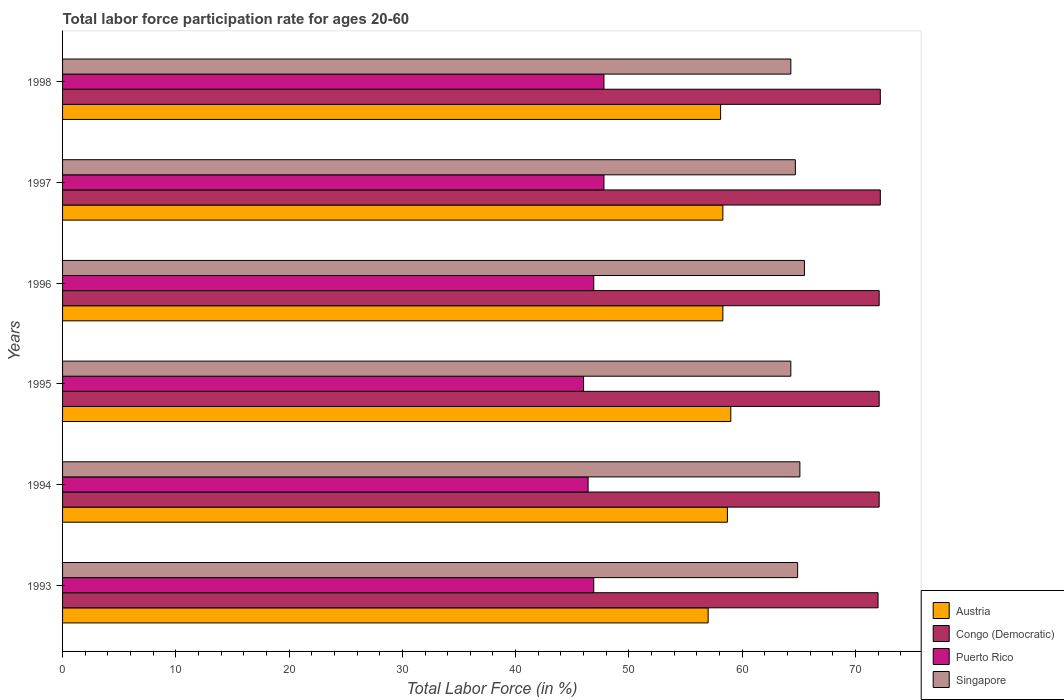Are the number of bars per tick equal to the number of legend labels?
Offer a terse response. Yes. Are the number of bars on each tick of the Y-axis equal?
Your answer should be compact. Yes. How many bars are there on the 6th tick from the top?
Your answer should be very brief. 4. What is the label of the 4th group of bars from the top?
Your response must be concise. 1995. In how many cases, is the number of bars for a given year not equal to the number of legend labels?
Your response must be concise. 0. What is the labor force participation rate in Congo (Democratic) in 1998?
Ensure brevity in your answer.  72.2. Across all years, what is the maximum labor force participation rate in Congo (Democratic)?
Provide a short and direct response. 72.2. Across all years, what is the minimum labor force participation rate in Singapore?
Keep it short and to the point. 64.3. In which year was the labor force participation rate in Congo (Democratic) maximum?
Your response must be concise. 1997. In which year was the labor force participation rate in Singapore minimum?
Your answer should be very brief. 1995. What is the total labor force participation rate in Puerto Rico in the graph?
Offer a very short reply. 281.8. What is the difference between the labor force participation rate in Congo (Democratic) in 1994 and that in 1997?
Give a very brief answer. -0.1. What is the difference between the labor force participation rate in Congo (Democratic) in 1993 and the labor force participation rate in Austria in 1998?
Your response must be concise. 13.9. What is the average labor force participation rate in Austria per year?
Keep it short and to the point. 58.23. In the year 1998, what is the difference between the labor force participation rate in Puerto Rico and labor force participation rate in Singapore?
Offer a very short reply. -16.5. What is the ratio of the labor force participation rate in Austria in 1997 to that in 1998?
Your answer should be compact. 1. Is the labor force participation rate in Austria in 1994 less than that in 1998?
Provide a succinct answer. No. What is the difference between the highest and the second highest labor force participation rate in Congo (Democratic)?
Provide a succinct answer. 0. What is the difference between the highest and the lowest labor force participation rate in Singapore?
Your answer should be compact. 1.2. In how many years, is the labor force participation rate in Puerto Rico greater than the average labor force participation rate in Puerto Rico taken over all years?
Offer a very short reply. 2. Is the sum of the labor force participation rate in Puerto Rico in 1995 and 1998 greater than the maximum labor force participation rate in Austria across all years?
Make the answer very short. Yes. What does the 2nd bar from the top in 1995 represents?
Give a very brief answer. Puerto Rico. What does the 2nd bar from the bottom in 1998 represents?
Offer a very short reply. Congo (Democratic). Is it the case that in every year, the sum of the labor force participation rate in Puerto Rico and labor force participation rate in Congo (Democratic) is greater than the labor force participation rate in Singapore?
Your response must be concise. Yes. How many bars are there?
Offer a very short reply. 24. How many years are there in the graph?
Make the answer very short. 6. Does the graph contain any zero values?
Offer a very short reply. No. Does the graph contain grids?
Ensure brevity in your answer.  No. What is the title of the graph?
Your response must be concise. Total labor force participation rate for ages 20-60. What is the label or title of the X-axis?
Keep it short and to the point. Total Labor Force (in %). What is the label or title of the Y-axis?
Your answer should be very brief. Years. What is the Total Labor Force (in %) in Puerto Rico in 1993?
Give a very brief answer. 46.9. What is the Total Labor Force (in %) in Singapore in 1993?
Keep it short and to the point. 64.9. What is the Total Labor Force (in %) in Austria in 1994?
Make the answer very short. 58.7. What is the Total Labor Force (in %) of Congo (Democratic) in 1994?
Your response must be concise. 72.1. What is the Total Labor Force (in %) in Puerto Rico in 1994?
Ensure brevity in your answer.  46.4. What is the Total Labor Force (in %) of Singapore in 1994?
Give a very brief answer. 65.1. What is the Total Labor Force (in %) of Congo (Democratic) in 1995?
Keep it short and to the point. 72.1. What is the Total Labor Force (in %) of Puerto Rico in 1995?
Your answer should be very brief. 46. What is the Total Labor Force (in %) in Singapore in 1995?
Your response must be concise. 64.3. What is the Total Labor Force (in %) of Austria in 1996?
Provide a short and direct response. 58.3. What is the Total Labor Force (in %) in Congo (Democratic) in 1996?
Provide a short and direct response. 72.1. What is the Total Labor Force (in %) of Puerto Rico in 1996?
Make the answer very short. 46.9. What is the Total Labor Force (in %) of Singapore in 1996?
Offer a very short reply. 65.5. What is the Total Labor Force (in %) in Austria in 1997?
Give a very brief answer. 58.3. What is the Total Labor Force (in %) of Congo (Democratic) in 1997?
Ensure brevity in your answer.  72.2. What is the Total Labor Force (in %) of Puerto Rico in 1997?
Give a very brief answer. 47.8. What is the Total Labor Force (in %) in Singapore in 1997?
Keep it short and to the point. 64.7. What is the Total Labor Force (in %) in Austria in 1998?
Provide a succinct answer. 58.1. What is the Total Labor Force (in %) of Congo (Democratic) in 1998?
Provide a succinct answer. 72.2. What is the Total Labor Force (in %) in Puerto Rico in 1998?
Ensure brevity in your answer.  47.8. What is the Total Labor Force (in %) of Singapore in 1998?
Provide a short and direct response. 64.3. Across all years, what is the maximum Total Labor Force (in %) in Austria?
Give a very brief answer. 59. Across all years, what is the maximum Total Labor Force (in %) in Congo (Democratic)?
Your answer should be compact. 72.2. Across all years, what is the maximum Total Labor Force (in %) in Puerto Rico?
Your answer should be very brief. 47.8. Across all years, what is the maximum Total Labor Force (in %) of Singapore?
Your answer should be very brief. 65.5. Across all years, what is the minimum Total Labor Force (in %) of Austria?
Provide a short and direct response. 57. Across all years, what is the minimum Total Labor Force (in %) in Congo (Democratic)?
Keep it short and to the point. 72. Across all years, what is the minimum Total Labor Force (in %) in Puerto Rico?
Make the answer very short. 46. Across all years, what is the minimum Total Labor Force (in %) in Singapore?
Your answer should be compact. 64.3. What is the total Total Labor Force (in %) in Austria in the graph?
Your response must be concise. 349.4. What is the total Total Labor Force (in %) of Congo (Democratic) in the graph?
Your answer should be compact. 432.7. What is the total Total Labor Force (in %) of Puerto Rico in the graph?
Your response must be concise. 281.8. What is the total Total Labor Force (in %) of Singapore in the graph?
Keep it short and to the point. 388.8. What is the difference between the Total Labor Force (in %) in Austria in 1993 and that in 1994?
Provide a succinct answer. -1.7. What is the difference between the Total Labor Force (in %) in Congo (Democratic) in 1993 and that in 1994?
Offer a very short reply. -0.1. What is the difference between the Total Labor Force (in %) in Puerto Rico in 1993 and that in 1994?
Your response must be concise. 0.5. What is the difference between the Total Labor Force (in %) of Austria in 1993 and that in 1995?
Your answer should be compact. -2. What is the difference between the Total Labor Force (in %) of Congo (Democratic) in 1993 and that in 1995?
Ensure brevity in your answer.  -0.1. What is the difference between the Total Labor Force (in %) in Puerto Rico in 1993 and that in 1995?
Offer a terse response. 0.9. What is the difference between the Total Labor Force (in %) in Singapore in 1993 and that in 1995?
Keep it short and to the point. 0.6. What is the difference between the Total Labor Force (in %) of Austria in 1993 and that in 1996?
Your answer should be very brief. -1.3. What is the difference between the Total Labor Force (in %) of Congo (Democratic) in 1993 and that in 1996?
Your response must be concise. -0.1. What is the difference between the Total Labor Force (in %) of Austria in 1993 and that in 1997?
Keep it short and to the point. -1.3. What is the difference between the Total Labor Force (in %) of Austria in 1993 and that in 1998?
Provide a short and direct response. -1.1. What is the difference between the Total Labor Force (in %) in Congo (Democratic) in 1993 and that in 1998?
Give a very brief answer. -0.2. What is the difference between the Total Labor Force (in %) of Puerto Rico in 1993 and that in 1998?
Your response must be concise. -0.9. What is the difference between the Total Labor Force (in %) of Austria in 1994 and that in 1995?
Offer a very short reply. -0.3. What is the difference between the Total Labor Force (in %) in Congo (Democratic) in 1994 and that in 1995?
Your answer should be very brief. 0. What is the difference between the Total Labor Force (in %) in Puerto Rico in 1994 and that in 1995?
Make the answer very short. 0.4. What is the difference between the Total Labor Force (in %) of Singapore in 1994 and that in 1995?
Keep it short and to the point. 0.8. What is the difference between the Total Labor Force (in %) of Congo (Democratic) in 1994 and that in 1996?
Give a very brief answer. 0. What is the difference between the Total Labor Force (in %) in Puerto Rico in 1994 and that in 1996?
Provide a succinct answer. -0.5. What is the difference between the Total Labor Force (in %) of Singapore in 1994 and that in 1996?
Ensure brevity in your answer.  -0.4. What is the difference between the Total Labor Force (in %) of Puerto Rico in 1994 and that in 1997?
Your response must be concise. -1.4. What is the difference between the Total Labor Force (in %) in Singapore in 1994 and that in 1997?
Give a very brief answer. 0.4. What is the difference between the Total Labor Force (in %) in Austria in 1994 and that in 1998?
Your answer should be very brief. 0.6. What is the difference between the Total Labor Force (in %) in Congo (Democratic) in 1994 and that in 1998?
Give a very brief answer. -0.1. What is the difference between the Total Labor Force (in %) of Puerto Rico in 1994 and that in 1998?
Give a very brief answer. -1.4. What is the difference between the Total Labor Force (in %) in Austria in 1995 and that in 1996?
Give a very brief answer. 0.7. What is the difference between the Total Labor Force (in %) in Puerto Rico in 1995 and that in 1996?
Provide a short and direct response. -0.9. What is the difference between the Total Labor Force (in %) in Singapore in 1995 and that in 1996?
Keep it short and to the point. -1.2. What is the difference between the Total Labor Force (in %) of Congo (Democratic) in 1995 and that in 1997?
Make the answer very short. -0.1. What is the difference between the Total Labor Force (in %) in Singapore in 1995 and that in 1997?
Offer a very short reply. -0.4. What is the difference between the Total Labor Force (in %) in Austria in 1995 and that in 1998?
Ensure brevity in your answer.  0.9. What is the difference between the Total Labor Force (in %) in Congo (Democratic) in 1995 and that in 1998?
Provide a short and direct response. -0.1. What is the difference between the Total Labor Force (in %) of Puerto Rico in 1995 and that in 1998?
Provide a succinct answer. -1.8. What is the difference between the Total Labor Force (in %) in Puerto Rico in 1996 and that in 1997?
Offer a terse response. -0.9. What is the difference between the Total Labor Force (in %) of Singapore in 1996 and that in 1997?
Keep it short and to the point. 0.8. What is the difference between the Total Labor Force (in %) of Austria in 1996 and that in 1998?
Offer a very short reply. 0.2. What is the difference between the Total Labor Force (in %) in Congo (Democratic) in 1996 and that in 1998?
Give a very brief answer. -0.1. What is the difference between the Total Labor Force (in %) in Puerto Rico in 1996 and that in 1998?
Provide a short and direct response. -0.9. What is the difference between the Total Labor Force (in %) in Congo (Democratic) in 1997 and that in 1998?
Your answer should be compact. 0. What is the difference between the Total Labor Force (in %) in Singapore in 1997 and that in 1998?
Ensure brevity in your answer.  0.4. What is the difference between the Total Labor Force (in %) in Austria in 1993 and the Total Labor Force (in %) in Congo (Democratic) in 1994?
Offer a very short reply. -15.1. What is the difference between the Total Labor Force (in %) of Austria in 1993 and the Total Labor Force (in %) of Puerto Rico in 1994?
Your response must be concise. 10.6. What is the difference between the Total Labor Force (in %) in Congo (Democratic) in 1993 and the Total Labor Force (in %) in Puerto Rico in 1994?
Your answer should be very brief. 25.6. What is the difference between the Total Labor Force (in %) in Congo (Democratic) in 1993 and the Total Labor Force (in %) in Singapore in 1994?
Offer a terse response. 6.9. What is the difference between the Total Labor Force (in %) in Puerto Rico in 1993 and the Total Labor Force (in %) in Singapore in 1994?
Your answer should be compact. -18.2. What is the difference between the Total Labor Force (in %) of Austria in 1993 and the Total Labor Force (in %) of Congo (Democratic) in 1995?
Your answer should be compact. -15.1. What is the difference between the Total Labor Force (in %) in Austria in 1993 and the Total Labor Force (in %) in Puerto Rico in 1995?
Provide a succinct answer. 11. What is the difference between the Total Labor Force (in %) of Austria in 1993 and the Total Labor Force (in %) of Singapore in 1995?
Your response must be concise. -7.3. What is the difference between the Total Labor Force (in %) of Congo (Democratic) in 1993 and the Total Labor Force (in %) of Puerto Rico in 1995?
Ensure brevity in your answer.  26. What is the difference between the Total Labor Force (in %) of Congo (Democratic) in 1993 and the Total Labor Force (in %) of Singapore in 1995?
Offer a very short reply. 7.7. What is the difference between the Total Labor Force (in %) in Puerto Rico in 1993 and the Total Labor Force (in %) in Singapore in 1995?
Provide a short and direct response. -17.4. What is the difference between the Total Labor Force (in %) in Austria in 1993 and the Total Labor Force (in %) in Congo (Democratic) in 1996?
Offer a terse response. -15.1. What is the difference between the Total Labor Force (in %) of Congo (Democratic) in 1993 and the Total Labor Force (in %) of Puerto Rico in 1996?
Provide a short and direct response. 25.1. What is the difference between the Total Labor Force (in %) of Congo (Democratic) in 1993 and the Total Labor Force (in %) of Singapore in 1996?
Your answer should be very brief. 6.5. What is the difference between the Total Labor Force (in %) of Puerto Rico in 1993 and the Total Labor Force (in %) of Singapore in 1996?
Offer a terse response. -18.6. What is the difference between the Total Labor Force (in %) of Austria in 1993 and the Total Labor Force (in %) of Congo (Democratic) in 1997?
Your response must be concise. -15.2. What is the difference between the Total Labor Force (in %) in Austria in 1993 and the Total Labor Force (in %) in Puerto Rico in 1997?
Provide a short and direct response. 9.2. What is the difference between the Total Labor Force (in %) of Congo (Democratic) in 1993 and the Total Labor Force (in %) of Puerto Rico in 1997?
Your response must be concise. 24.2. What is the difference between the Total Labor Force (in %) in Congo (Democratic) in 1993 and the Total Labor Force (in %) in Singapore in 1997?
Provide a short and direct response. 7.3. What is the difference between the Total Labor Force (in %) of Puerto Rico in 1993 and the Total Labor Force (in %) of Singapore in 1997?
Keep it short and to the point. -17.8. What is the difference between the Total Labor Force (in %) in Austria in 1993 and the Total Labor Force (in %) in Congo (Democratic) in 1998?
Make the answer very short. -15.2. What is the difference between the Total Labor Force (in %) of Austria in 1993 and the Total Labor Force (in %) of Puerto Rico in 1998?
Keep it short and to the point. 9.2. What is the difference between the Total Labor Force (in %) in Austria in 1993 and the Total Labor Force (in %) in Singapore in 1998?
Make the answer very short. -7.3. What is the difference between the Total Labor Force (in %) of Congo (Democratic) in 1993 and the Total Labor Force (in %) of Puerto Rico in 1998?
Your answer should be compact. 24.2. What is the difference between the Total Labor Force (in %) in Puerto Rico in 1993 and the Total Labor Force (in %) in Singapore in 1998?
Ensure brevity in your answer.  -17.4. What is the difference between the Total Labor Force (in %) in Congo (Democratic) in 1994 and the Total Labor Force (in %) in Puerto Rico in 1995?
Ensure brevity in your answer.  26.1. What is the difference between the Total Labor Force (in %) in Puerto Rico in 1994 and the Total Labor Force (in %) in Singapore in 1995?
Offer a very short reply. -17.9. What is the difference between the Total Labor Force (in %) of Austria in 1994 and the Total Labor Force (in %) of Congo (Democratic) in 1996?
Give a very brief answer. -13.4. What is the difference between the Total Labor Force (in %) in Austria in 1994 and the Total Labor Force (in %) in Singapore in 1996?
Provide a short and direct response. -6.8. What is the difference between the Total Labor Force (in %) in Congo (Democratic) in 1994 and the Total Labor Force (in %) in Puerto Rico in 1996?
Offer a very short reply. 25.2. What is the difference between the Total Labor Force (in %) in Congo (Democratic) in 1994 and the Total Labor Force (in %) in Singapore in 1996?
Your answer should be very brief. 6.6. What is the difference between the Total Labor Force (in %) in Puerto Rico in 1994 and the Total Labor Force (in %) in Singapore in 1996?
Make the answer very short. -19.1. What is the difference between the Total Labor Force (in %) in Austria in 1994 and the Total Labor Force (in %) in Singapore in 1997?
Provide a short and direct response. -6. What is the difference between the Total Labor Force (in %) in Congo (Democratic) in 1994 and the Total Labor Force (in %) in Puerto Rico in 1997?
Provide a short and direct response. 24.3. What is the difference between the Total Labor Force (in %) in Congo (Democratic) in 1994 and the Total Labor Force (in %) in Singapore in 1997?
Ensure brevity in your answer.  7.4. What is the difference between the Total Labor Force (in %) of Puerto Rico in 1994 and the Total Labor Force (in %) of Singapore in 1997?
Your response must be concise. -18.3. What is the difference between the Total Labor Force (in %) in Austria in 1994 and the Total Labor Force (in %) in Congo (Democratic) in 1998?
Your answer should be very brief. -13.5. What is the difference between the Total Labor Force (in %) in Austria in 1994 and the Total Labor Force (in %) in Puerto Rico in 1998?
Your answer should be very brief. 10.9. What is the difference between the Total Labor Force (in %) in Austria in 1994 and the Total Labor Force (in %) in Singapore in 1998?
Your response must be concise. -5.6. What is the difference between the Total Labor Force (in %) in Congo (Democratic) in 1994 and the Total Labor Force (in %) in Puerto Rico in 1998?
Ensure brevity in your answer.  24.3. What is the difference between the Total Labor Force (in %) of Puerto Rico in 1994 and the Total Labor Force (in %) of Singapore in 1998?
Your response must be concise. -17.9. What is the difference between the Total Labor Force (in %) of Congo (Democratic) in 1995 and the Total Labor Force (in %) of Puerto Rico in 1996?
Your answer should be very brief. 25.2. What is the difference between the Total Labor Force (in %) of Congo (Democratic) in 1995 and the Total Labor Force (in %) of Singapore in 1996?
Give a very brief answer. 6.6. What is the difference between the Total Labor Force (in %) in Puerto Rico in 1995 and the Total Labor Force (in %) in Singapore in 1996?
Ensure brevity in your answer.  -19.5. What is the difference between the Total Labor Force (in %) in Austria in 1995 and the Total Labor Force (in %) in Congo (Democratic) in 1997?
Offer a very short reply. -13.2. What is the difference between the Total Labor Force (in %) in Austria in 1995 and the Total Labor Force (in %) in Puerto Rico in 1997?
Provide a short and direct response. 11.2. What is the difference between the Total Labor Force (in %) of Austria in 1995 and the Total Labor Force (in %) of Singapore in 1997?
Your answer should be very brief. -5.7. What is the difference between the Total Labor Force (in %) of Congo (Democratic) in 1995 and the Total Labor Force (in %) of Puerto Rico in 1997?
Provide a short and direct response. 24.3. What is the difference between the Total Labor Force (in %) in Puerto Rico in 1995 and the Total Labor Force (in %) in Singapore in 1997?
Make the answer very short. -18.7. What is the difference between the Total Labor Force (in %) of Austria in 1995 and the Total Labor Force (in %) of Singapore in 1998?
Keep it short and to the point. -5.3. What is the difference between the Total Labor Force (in %) in Congo (Democratic) in 1995 and the Total Labor Force (in %) in Puerto Rico in 1998?
Offer a very short reply. 24.3. What is the difference between the Total Labor Force (in %) in Puerto Rico in 1995 and the Total Labor Force (in %) in Singapore in 1998?
Offer a terse response. -18.3. What is the difference between the Total Labor Force (in %) in Austria in 1996 and the Total Labor Force (in %) in Singapore in 1997?
Your response must be concise. -6.4. What is the difference between the Total Labor Force (in %) of Congo (Democratic) in 1996 and the Total Labor Force (in %) of Puerto Rico in 1997?
Provide a short and direct response. 24.3. What is the difference between the Total Labor Force (in %) of Congo (Democratic) in 1996 and the Total Labor Force (in %) of Singapore in 1997?
Make the answer very short. 7.4. What is the difference between the Total Labor Force (in %) of Puerto Rico in 1996 and the Total Labor Force (in %) of Singapore in 1997?
Your response must be concise. -17.8. What is the difference between the Total Labor Force (in %) in Austria in 1996 and the Total Labor Force (in %) in Singapore in 1998?
Offer a very short reply. -6. What is the difference between the Total Labor Force (in %) of Congo (Democratic) in 1996 and the Total Labor Force (in %) of Puerto Rico in 1998?
Provide a short and direct response. 24.3. What is the difference between the Total Labor Force (in %) of Congo (Democratic) in 1996 and the Total Labor Force (in %) of Singapore in 1998?
Your answer should be compact. 7.8. What is the difference between the Total Labor Force (in %) in Puerto Rico in 1996 and the Total Labor Force (in %) in Singapore in 1998?
Provide a succinct answer. -17.4. What is the difference between the Total Labor Force (in %) of Austria in 1997 and the Total Labor Force (in %) of Singapore in 1998?
Keep it short and to the point. -6. What is the difference between the Total Labor Force (in %) in Congo (Democratic) in 1997 and the Total Labor Force (in %) in Puerto Rico in 1998?
Offer a terse response. 24.4. What is the difference between the Total Labor Force (in %) of Congo (Democratic) in 1997 and the Total Labor Force (in %) of Singapore in 1998?
Give a very brief answer. 7.9. What is the difference between the Total Labor Force (in %) in Puerto Rico in 1997 and the Total Labor Force (in %) in Singapore in 1998?
Your answer should be very brief. -16.5. What is the average Total Labor Force (in %) of Austria per year?
Ensure brevity in your answer.  58.23. What is the average Total Labor Force (in %) of Congo (Democratic) per year?
Give a very brief answer. 72.12. What is the average Total Labor Force (in %) in Puerto Rico per year?
Offer a very short reply. 46.97. What is the average Total Labor Force (in %) of Singapore per year?
Your answer should be very brief. 64.8. In the year 1993, what is the difference between the Total Labor Force (in %) in Austria and Total Labor Force (in %) in Singapore?
Offer a terse response. -7.9. In the year 1993, what is the difference between the Total Labor Force (in %) of Congo (Democratic) and Total Labor Force (in %) of Puerto Rico?
Provide a short and direct response. 25.1. In the year 1993, what is the difference between the Total Labor Force (in %) of Congo (Democratic) and Total Labor Force (in %) of Singapore?
Offer a very short reply. 7.1. In the year 1993, what is the difference between the Total Labor Force (in %) of Puerto Rico and Total Labor Force (in %) of Singapore?
Your answer should be compact. -18. In the year 1994, what is the difference between the Total Labor Force (in %) in Austria and Total Labor Force (in %) in Congo (Democratic)?
Your answer should be very brief. -13.4. In the year 1994, what is the difference between the Total Labor Force (in %) of Congo (Democratic) and Total Labor Force (in %) of Puerto Rico?
Ensure brevity in your answer.  25.7. In the year 1994, what is the difference between the Total Labor Force (in %) in Puerto Rico and Total Labor Force (in %) in Singapore?
Make the answer very short. -18.7. In the year 1995, what is the difference between the Total Labor Force (in %) in Austria and Total Labor Force (in %) in Congo (Democratic)?
Keep it short and to the point. -13.1. In the year 1995, what is the difference between the Total Labor Force (in %) of Congo (Democratic) and Total Labor Force (in %) of Puerto Rico?
Your answer should be compact. 26.1. In the year 1995, what is the difference between the Total Labor Force (in %) in Puerto Rico and Total Labor Force (in %) in Singapore?
Offer a terse response. -18.3. In the year 1996, what is the difference between the Total Labor Force (in %) of Austria and Total Labor Force (in %) of Congo (Democratic)?
Ensure brevity in your answer.  -13.8. In the year 1996, what is the difference between the Total Labor Force (in %) of Austria and Total Labor Force (in %) of Singapore?
Make the answer very short. -7.2. In the year 1996, what is the difference between the Total Labor Force (in %) of Congo (Democratic) and Total Labor Force (in %) of Puerto Rico?
Make the answer very short. 25.2. In the year 1996, what is the difference between the Total Labor Force (in %) in Congo (Democratic) and Total Labor Force (in %) in Singapore?
Offer a terse response. 6.6. In the year 1996, what is the difference between the Total Labor Force (in %) in Puerto Rico and Total Labor Force (in %) in Singapore?
Your response must be concise. -18.6. In the year 1997, what is the difference between the Total Labor Force (in %) of Austria and Total Labor Force (in %) of Singapore?
Your answer should be very brief. -6.4. In the year 1997, what is the difference between the Total Labor Force (in %) of Congo (Democratic) and Total Labor Force (in %) of Puerto Rico?
Provide a succinct answer. 24.4. In the year 1997, what is the difference between the Total Labor Force (in %) in Congo (Democratic) and Total Labor Force (in %) in Singapore?
Make the answer very short. 7.5. In the year 1997, what is the difference between the Total Labor Force (in %) of Puerto Rico and Total Labor Force (in %) of Singapore?
Make the answer very short. -16.9. In the year 1998, what is the difference between the Total Labor Force (in %) in Austria and Total Labor Force (in %) in Congo (Democratic)?
Offer a very short reply. -14.1. In the year 1998, what is the difference between the Total Labor Force (in %) in Austria and Total Labor Force (in %) in Singapore?
Your answer should be compact. -6.2. In the year 1998, what is the difference between the Total Labor Force (in %) in Congo (Democratic) and Total Labor Force (in %) in Puerto Rico?
Make the answer very short. 24.4. In the year 1998, what is the difference between the Total Labor Force (in %) in Congo (Democratic) and Total Labor Force (in %) in Singapore?
Ensure brevity in your answer.  7.9. In the year 1998, what is the difference between the Total Labor Force (in %) in Puerto Rico and Total Labor Force (in %) in Singapore?
Provide a short and direct response. -16.5. What is the ratio of the Total Labor Force (in %) in Congo (Democratic) in 1993 to that in 1994?
Your response must be concise. 1. What is the ratio of the Total Labor Force (in %) in Puerto Rico in 1993 to that in 1994?
Ensure brevity in your answer.  1.01. What is the ratio of the Total Labor Force (in %) in Singapore in 1993 to that in 1994?
Offer a very short reply. 1. What is the ratio of the Total Labor Force (in %) in Austria in 1993 to that in 1995?
Ensure brevity in your answer.  0.97. What is the ratio of the Total Labor Force (in %) of Congo (Democratic) in 1993 to that in 1995?
Provide a short and direct response. 1. What is the ratio of the Total Labor Force (in %) in Puerto Rico in 1993 to that in 1995?
Ensure brevity in your answer.  1.02. What is the ratio of the Total Labor Force (in %) in Singapore in 1993 to that in 1995?
Ensure brevity in your answer.  1.01. What is the ratio of the Total Labor Force (in %) of Austria in 1993 to that in 1996?
Your response must be concise. 0.98. What is the ratio of the Total Labor Force (in %) of Congo (Democratic) in 1993 to that in 1996?
Make the answer very short. 1. What is the ratio of the Total Labor Force (in %) of Austria in 1993 to that in 1997?
Your answer should be very brief. 0.98. What is the ratio of the Total Labor Force (in %) of Congo (Democratic) in 1993 to that in 1997?
Ensure brevity in your answer.  1. What is the ratio of the Total Labor Force (in %) in Puerto Rico in 1993 to that in 1997?
Your response must be concise. 0.98. What is the ratio of the Total Labor Force (in %) in Austria in 1993 to that in 1998?
Provide a succinct answer. 0.98. What is the ratio of the Total Labor Force (in %) of Puerto Rico in 1993 to that in 1998?
Provide a succinct answer. 0.98. What is the ratio of the Total Labor Force (in %) of Singapore in 1993 to that in 1998?
Your answer should be very brief. 1.01. What is the ratio of the Total Labor Force (in %) of Austria in 1994 to that in 1995?
Ensure brevity in your answer.  0.99. What is the ratio of the Total Labor Force (in %) in Puerto Rico in 1994 to that in 1995?
Offer a very short reply. 1.01. What is the ratio of the Total Labor Force (in %) of Singapore in 1994 to that in 1995?
Your response must be concise. 1.01. What is the ratio of the Total Labor Force (in %) of Austria in 1994 to that in 1996?
Provide a short and direct response. 1.01. What is the ratio of the Total Labor Force (in %) of Puerto Rico in 1994 to that in 1996?
Give a very brief answer. 0.99. What is the ratio of the Total Labor Force (in %) in Singapore in 1994 to that in 1996?
Your response must be concise. 0.99. What is the ratio of the Total Labor Force (in %) of Austria in 1994 to that in 1997?
Your answer should be compact. 1.01. What is the ratio of the Total Labor Force (in %) of Congo (Democratic) in 1994 to that in 1997?
Keep it short and to the point. 1. What is the ratio of the Total Labor Force (in %) in Puerto Rico in 1994 to that in 1997?
Provide a succinct answer. 0.97. What is the ratio of the Total Labor Force (in %) in Singapore in 1994 to that in 1997?
Provide a succinct answer. 1.01. What is the ratio of the Total Labor Force (in %) in Austria in 1994 to that in 1998?
Make the answer very short. 1.01. What is the ratio of the Total Labor Force (in %) of Congo (Democratic) in 1994 to that in 1998?
Provide a succinct answer. 1. What is the ratio of the Total Labor Force (in %) of Puerto Rico in 1994 to that in 1998?
Provide a short and direct response. 0.97. What is the ratio of the Total Labor Force (in %) in Singapore in 1994 to that in 1998?
Your answer should be very brief. 1.01. What is the ratio of the Total Labor Force (in %) in Puerto Rico in 1995 to that in 1996?
Offer a terse response. 0.98. What is the ratio of the Total Labor Force (in %) of Singapore in 1995 to that in 1996?
Make the answer very short. 0.98. What is the ratio of the Total Labor Force (in %) in Austria in 1995 to that in 1997?
Ensure brevity in your answer.  1.01. What is the ratio of the Total Labor Force (in %) of Puerto Rico in 1995 to that in 1997?
Your answer should be very brief. 0.96. What is the ratio of the Total Labor Force (in %) of Singapore in 1995 to that in 1997?
Your response must be concise. 0.99. What is the ratio of the Total Labor Force (in %) of Austria in 1995 to that in 1998?
Your answer should be compact. 1.02. What is the ratio of the Total Labor Force (in %) of Puerto Rico in 1995 to that in 1998?
Keep it short and to the point. 0.96. What is the ratio of the Total Labor Force (in %) in Austria in 1996 to that in 1997?
Provide a short and direct response. 1. What is the ratio of the Total Labor Force (in %) in Puerto Rico in 1996 to that in 1997?
Keep it short and to the point. 0.98. What is the ratio of the Total Labor Force (in %) in Singapore in 1996 to that in 1997?
Provide a succinct answer. 1.01. What is the ratio of the Total Labor Force (in %) in Puerto Rico in 1996 to that in 1998?
Your answer should be very brief. 0.98. What is the ratio of the Total Labor Force (in %) of Singapore in 1996 to that in 1998?
Ensure brevity in your answer.  1.02. What is the ratio of the Total Labor Force (in %) in Austria in 1997 to that in 1998?
Provide a short and direct response. 1. What is the ratio of the Total Labor Force (in %) of Congo (Democratic) in 1997 to that in 1998?
Your response must be concise. 1. What is the ratio of the Total Labor Force (in %) in Singapore in 1997 to that in 1998?
Your answer should be compact. 1.01. What is the difference between the highest and the second highest Total Labor Force (in %) in Congo (Democratic)?
Provide a succinct answer. 0. What is the difference between the highest and the second highest Total Labor Force (in %) of Puerto Rico?
Offer a very short reply. 0. What is the difference between the highest and the second highest Total Labor Force (in %) in Singapore?
Keep it short and to the point. 0.4. What is the difference between the highest and the lowest Total Labor Force (in %) of Austria?
Your answer should be compact. 2. What is the difference between the highest and the lowest Total Labor Force (in %) in Congo (Democratic)?
Provide a succinct answer. 0.2. What is the difference between the highest and the lowest Total Labor Force (in %) of Puerto Rico?
Provide a succinct answer. 1.8. 